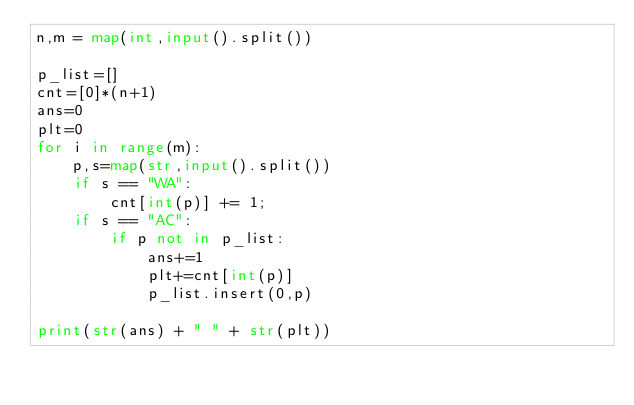<code> <loc_0><loc_0><loc_500><loc_500><_Python_>n,m = map(int,input().split())

p_list=[]
cnt=[0]*(n+1)
ans=0
plt=0
for i in range(m):
    p,s=map(str,input().split())
    if s == "WA":
        cnt[int(p)] += 1;
    if s == "AC":
        if p not in p_list:
            ans+=1
            plt+=cnt[int(p)]
            p_list.insert(0,p)
        
print(str(ans) + " " + str(plt))

</code> 